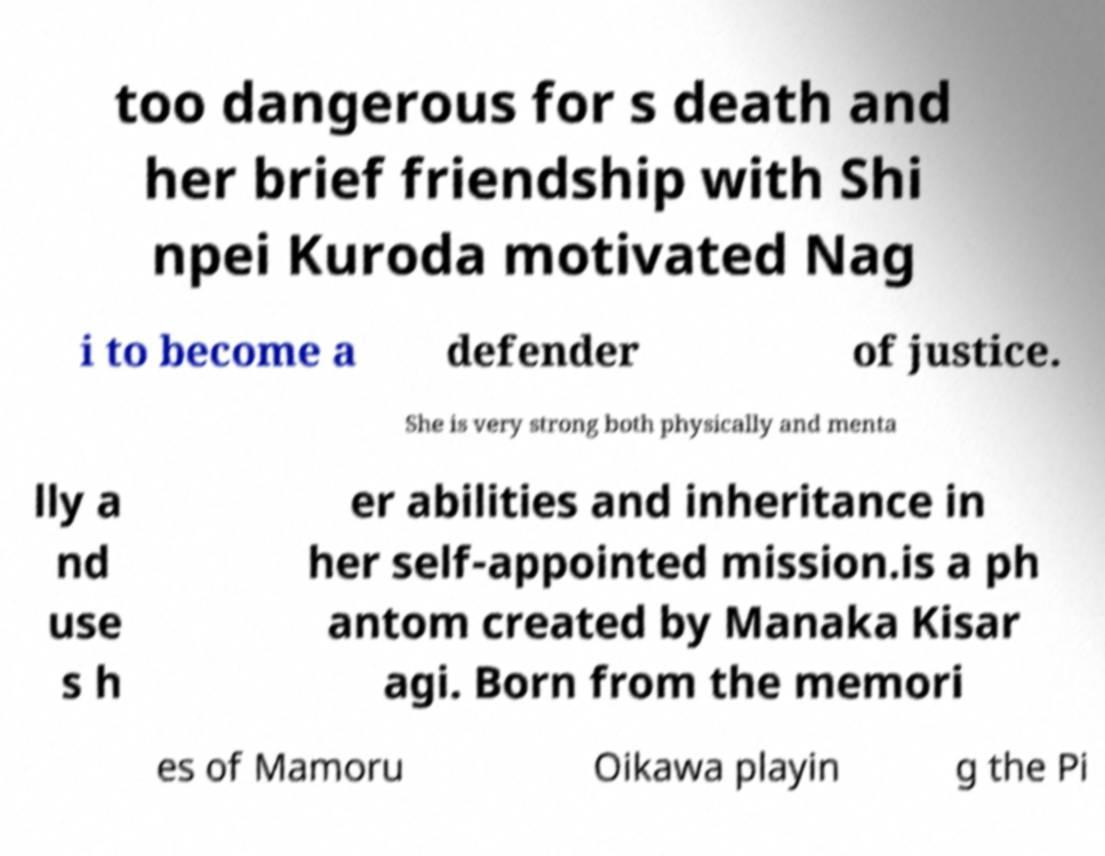Please identify and transcribe the text found in this image. too dangerous for s death and her brief friendship with Shi npei Kuroda motivated Nag i to become a defender of justice. She is very strong both physically and menta lly a nd use s h er abilities and inheritance in her self-appointed mission.is a ph antom created by Manaka Kisar agi. Born from the memori es of Mamoru Oikawa playin g the Pi 